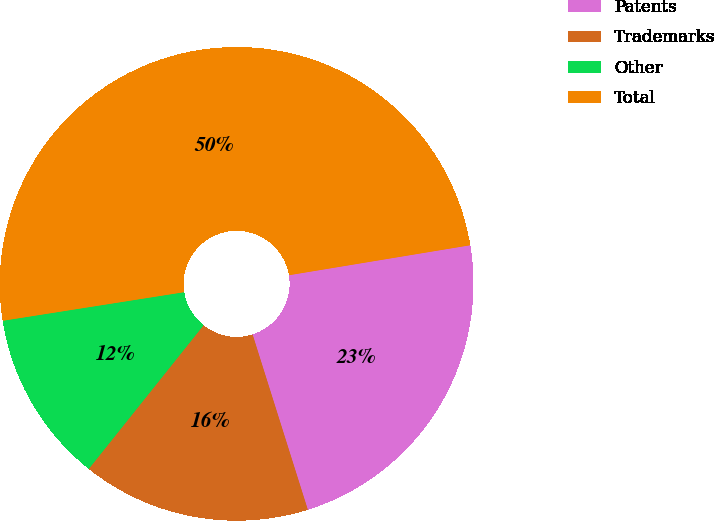<chart> <loc_0><loc_0><loc_500><loc_500><pie_chart><fcel>Patents<fcel>Trademarks<fcel>Other<fcel>Total<nl><fcel>22.75%<fcel>15.59%<fcel>11.78%<fcel>49.88%<nl></chart> 